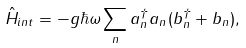Convert formula to latex. <formula><loc_0><loc_0><loc_500><loc_500>\hat { H } _ { i n t } = - g \hbar { \omega } \sum _ { n } a _ { n } ^ { \dagger } a _ { n } ( b _ { n } ^ { \dagger } + b _ { n } ) ,</formula> 